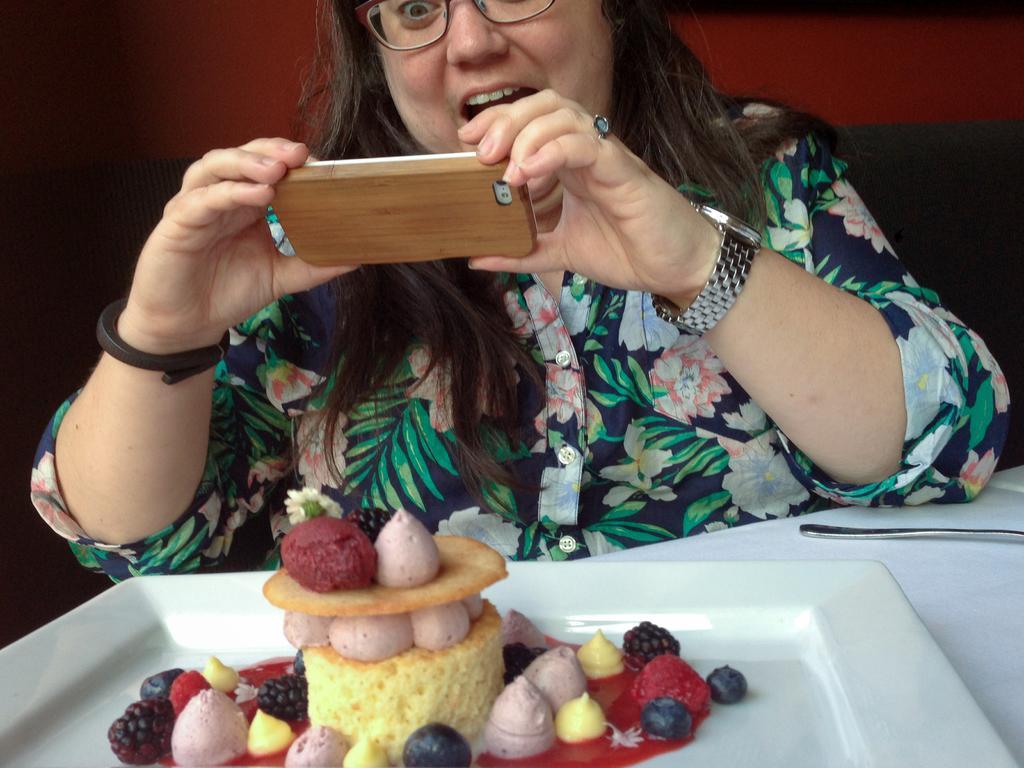Describe this image in one or two sentences. In the foreground of the image we can see some fruits and food placed on a plate and a spoon kept on the table. In the background, we can see a woman wearing a wrist watch is holding a mobile with her hands. 